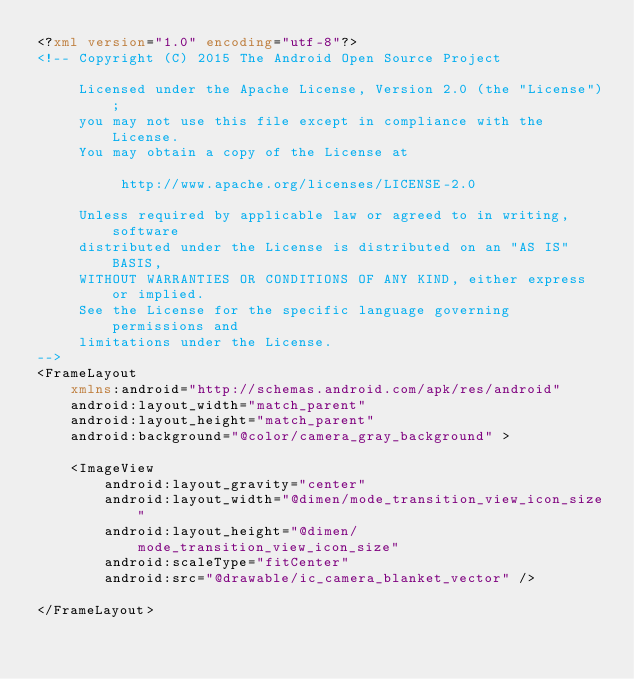<code> <loc_0><loc_0><loc_500><loc_500><_XML_><?xml version="1.0" encoding="utf-8"?>
<!-- Copyright (C) 2015 The Android Open Source Project

     Licensed under the Apache License, Version 2.0 (the "License");
     you may not use this file except in compliance with the License.
     You may obtain a copy of the License at

          http://www.apache.org/licenses/LICENSE-2.0

     Unless required by applicable law or agreed to in writing, software
     distributed under the License is distributed on an "AS IS" BASIS,
     WITHOUT WARRANTIES OR CONDITIONS OF ANY KIND, either express or implied.
     See the License for the specific language governing permissions and
     limitations under the License.
-->
<FrameLayout
    xmlns:android="http://schemas.android.com/apk/res/android"
    android:layout_width="match_parent"
    android:layout_height="match_parent"
    android:background="@color/camera_gray_background" >

    <ImageView
        android:layout_gravity="center"
        android:layout_width="@dimen/mode_transition_view_icon_size"
        android:layout_height="@dimen/mode_transition_view_icon_size"
        android:scaleType="fitCenter"
        android:src="@drawable/ic_camera_blanket_vector" />

</FrameLayout>
</code> 